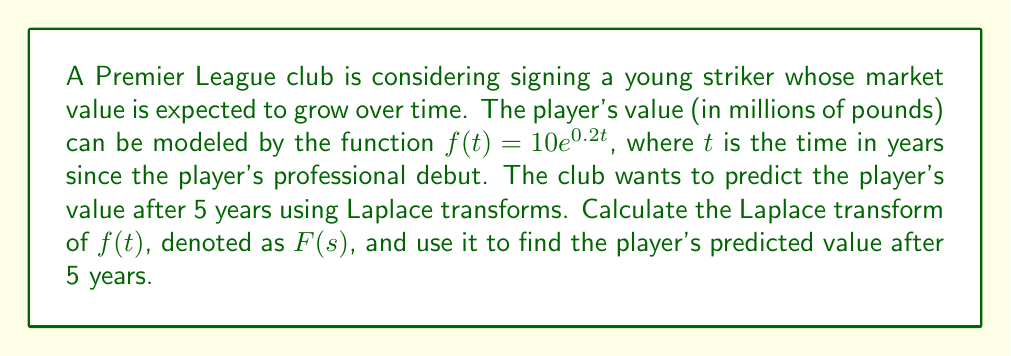Help me with this question. To solve this problem, we'll follow these steps:

1) First, let's recall the Laplace transform of the exponential function:
   $$\mathcal{L}\{e^{at}\} = \frac{1}{s-a}$$

2) In our case, $f(t) = 10e^{0.2t}$, so $a = 0.2$ and we have a constant factor of 10.

3) Using the linearity property of Laplace transforms, we can write:
   $$F(s) = \mathcal{L}\{f(t)\} = 10 \cdot \mathcal{L}\{e^{0.2t}\} = \frac{10}{s-0.2}$$

4) Now that we have $F(s)$, we can use the inverse Laplace transform to find the player's value at any time $t$. However, we're specifically asked about the value after 5 years, so we can simply evaluate the original function at $t=5$:

   $$f(5) = 10e^{0.2 \cdot 5} = 10e$$

5) To calculate this:
   $$10e \approx 10 \cdot 2.71828 \approx 27.1828$$

Therefore, the player's predicted value after 5 years is approximately 27.18 million pounds.
Answer: The Laplace transform of $f(t)$ is $F(s) = \frac{10}{s-0.2}$, and the player's predicted value after 5 years is approximately £27.18 million. 